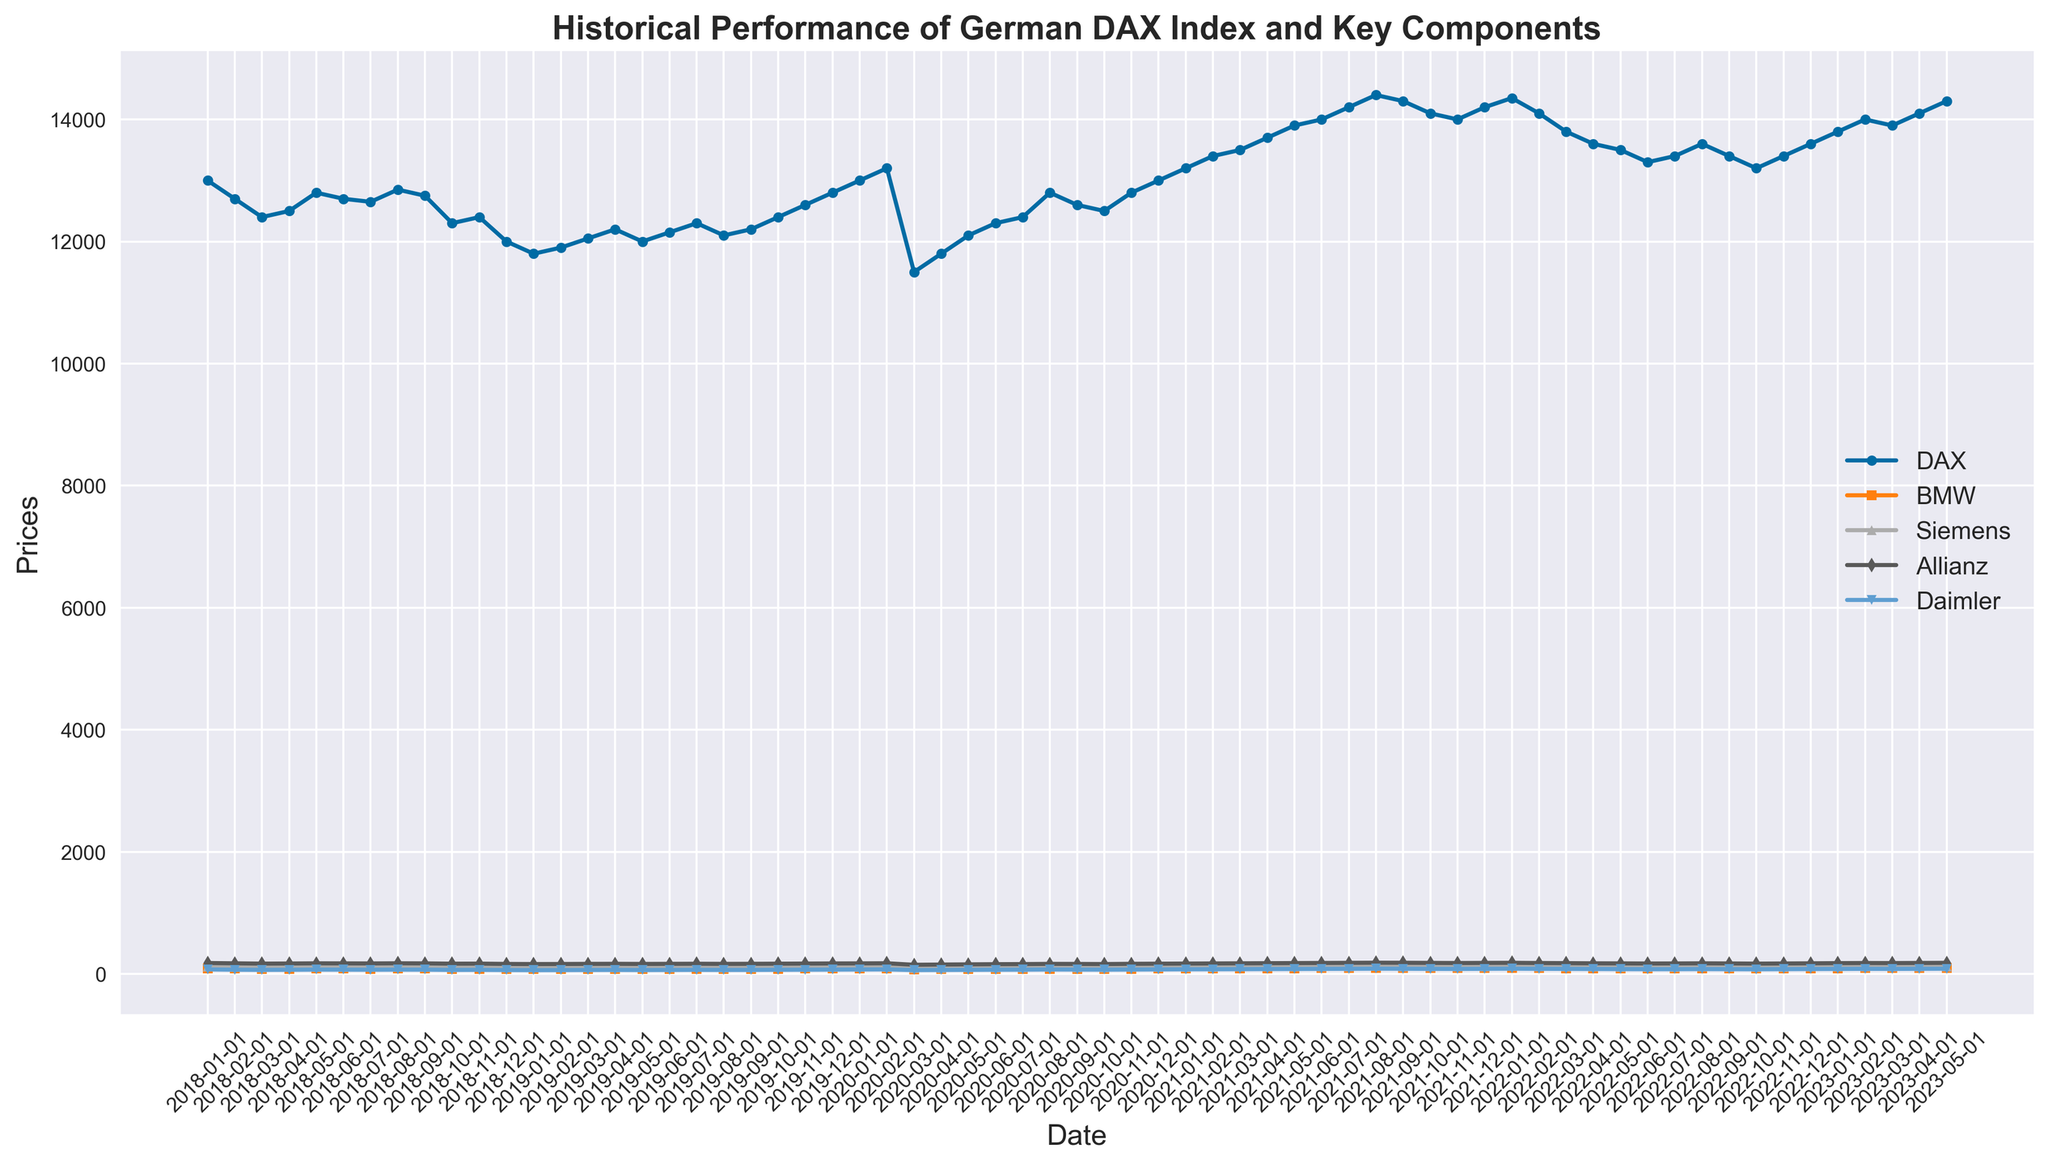Which component had the highest price at the beginning of 2023? Look at the markers for each component in January 2023 and find the highest one.
Answer: Allianz Which two components had the closest prices in May 2023? Compare the marker positions for all components and find the ones closest to each other.
Answer: Siemens and Daimler How did the DAX index change from January 2020 to March 2020? Locate these dates on the x-axis and compare the positions of the DAX line. Drop from around 13200 to 11500.
Answer: Decreased by 1700 points What was the trend for BMW in 2018? Observe the trend line for BMW across 2018 and note the overall direction.
Answer: Decreasing Which component had the highest price in February 2021? Locate February 2021 on the x-axis and identify the component with the highest marker.
Answer: Allianz Between which months in 2020 did Allianz see the most significant drop? Identify the steepest downward slope for Allianz in the year 2020.
Answer: February to March What is the average price of Siemens from June 2020 to June 2021? Sum the prices for Siemens from June 2020 to June 2021 and divide by the number of months (13).
Answer: (107 + 108.5 + 112 + 110.5 + 109 + 111 + 113 + 115 + 117 + 119 + 121 + 123 + 124) / 13 =  112.31 Which component had a quicker recovery after the drop in March 2020, BMW or Daimler? Compare the slopes of recovery lines for BMW and Daimler post-March 2020.
Answer: Daimler What was the lowest point of the DAX index between 2018 and 2023? Locate the lowest point of the DAX line between 2018 and 2023.
Answer: 11500 in March 2020 How did the price of Allianz trend compared to the DAX index in 2022? Observe the trend lines for both Allianz and the DAX index for 2022 and compare them.
Answer: Both trended downwards 